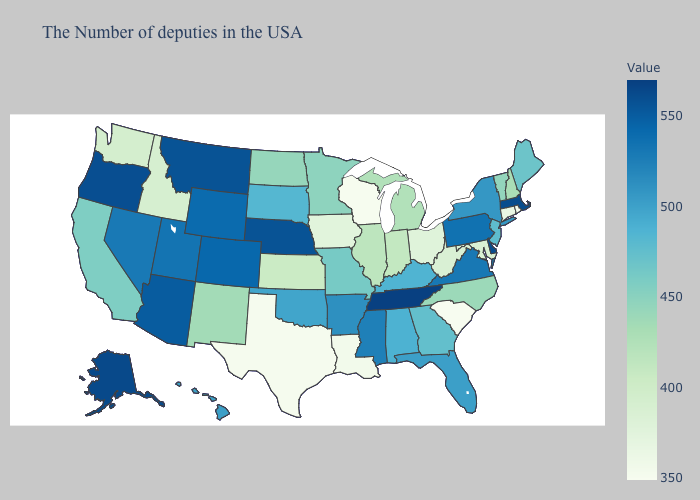Does Nebraska have the highest value in the USA?
Concise answer only. No. Does Oklahoma have the lowest value in the South?
Concise answer only. No. Among the states that border Florida , does Alabama have the lowest value?
Concise answer only. No. Does Rhode Island have the lowest value in the Northeast?
Be succinct. Yes. Among the states that border Texas , which have the lowest value?
Quick response, please. Louisiana. 